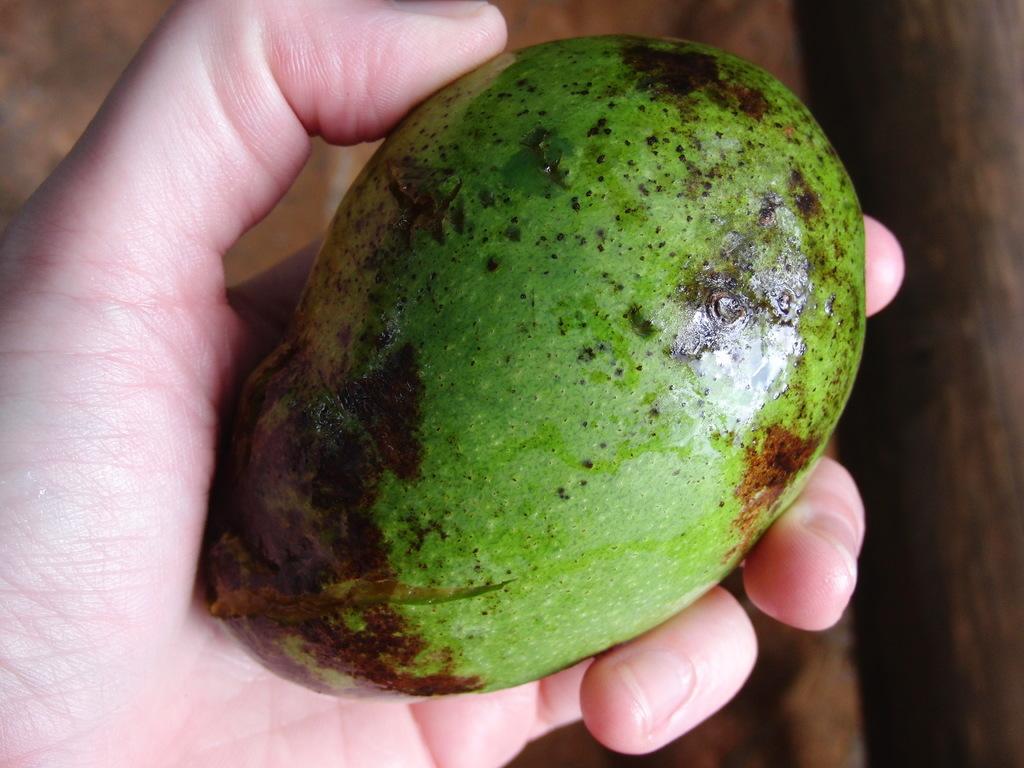Describe this image in one or two sentences. In this image I can see a hand of a person holding a mango. 